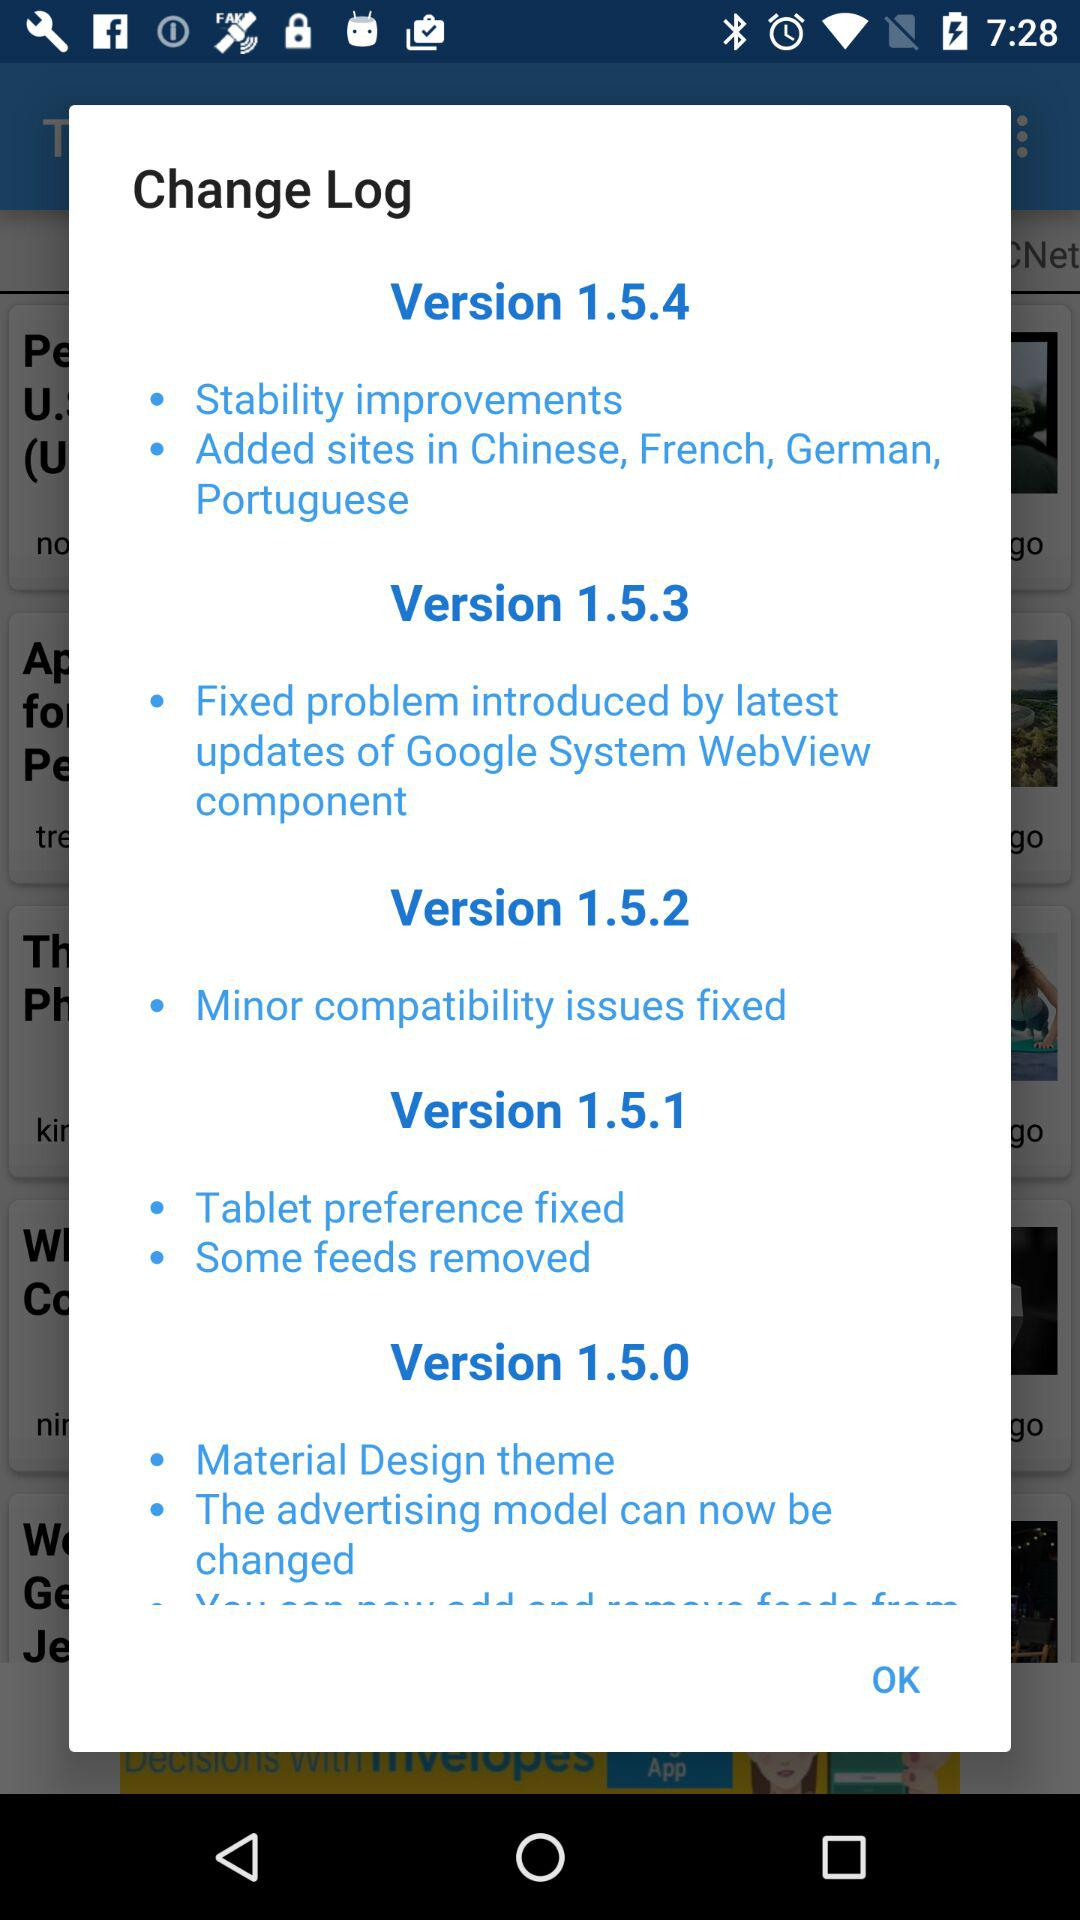Which version is the user using?
When the provided information is insufficient, respond with <no answer>. <no answer> 